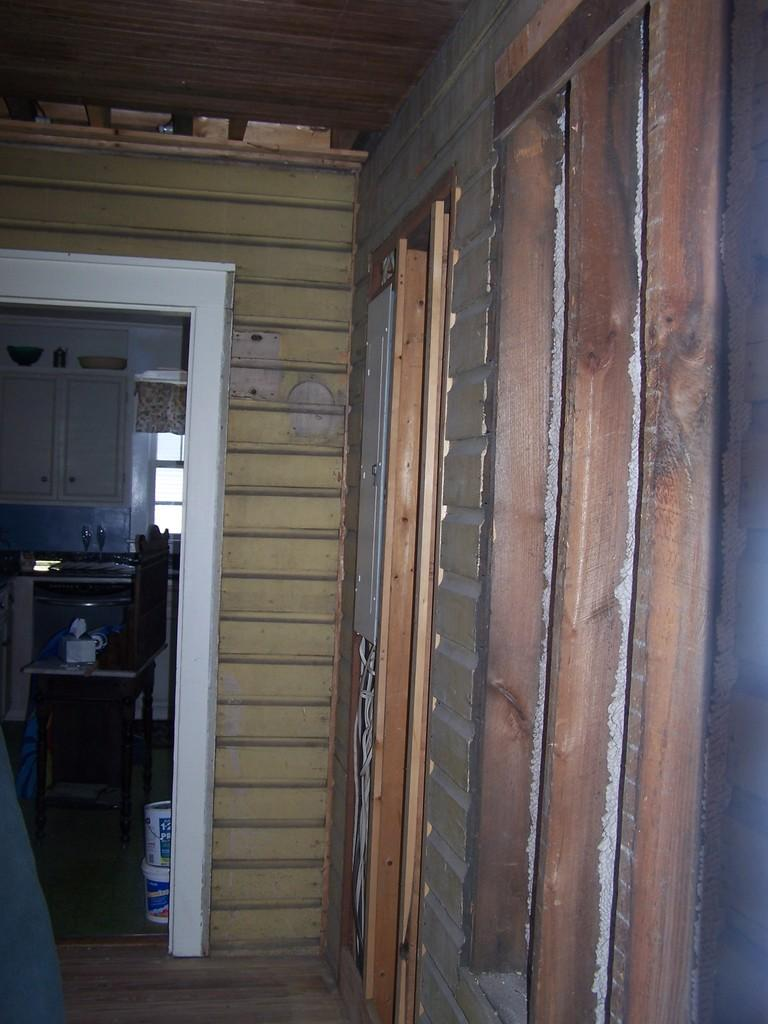What type of structure can be seen in the image? There is a wall in the image. What type of furniture is present in the image? There is a chair in the image. What type of storage unit is visible in the image? There is a cupboard in the image. What allows natural light into the room in the image? There is a window in the image. How many minutes does it take for the birth of a new idea in the image? There is no indication of a new idea being born in the image, nor is there any reference to time or duration. 